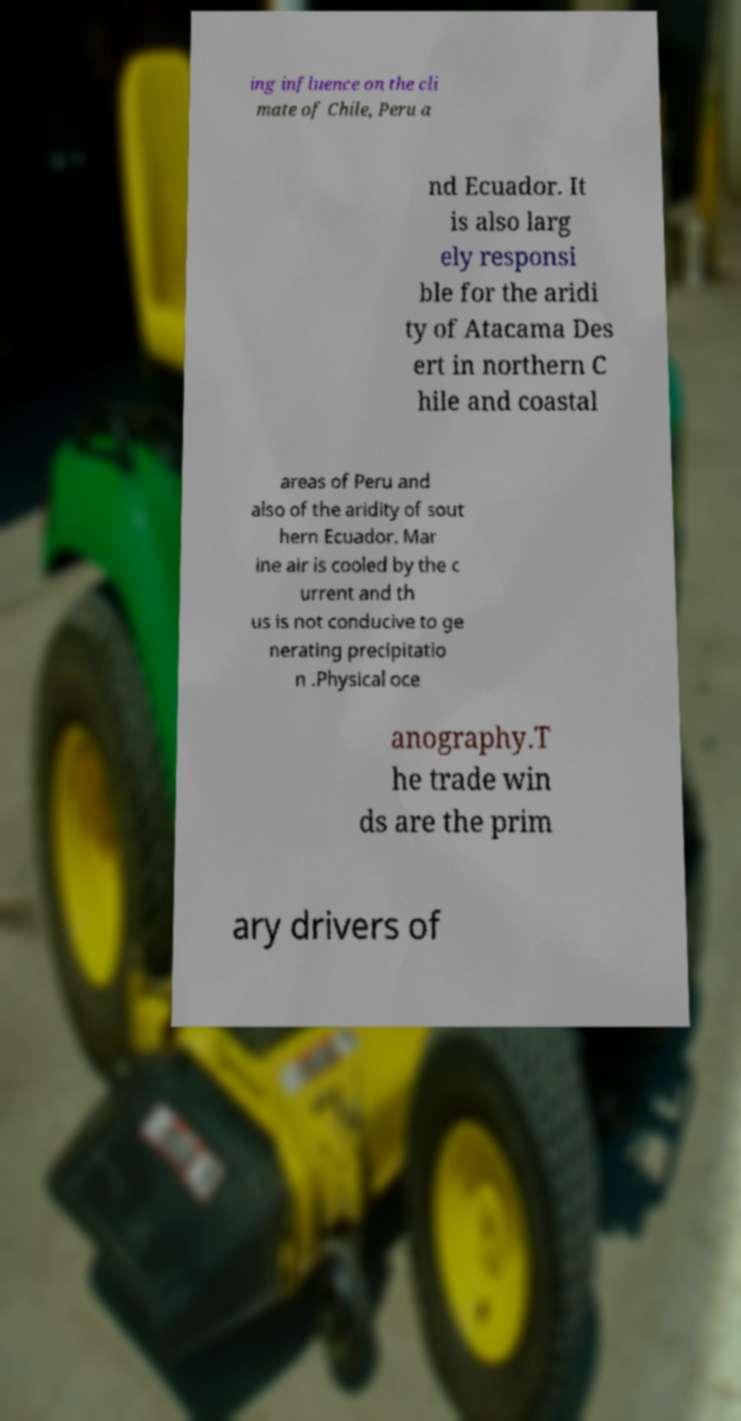For documentation purposes, I need the text within this image transcribed. Could you provide that? ing influence on the cli mate of Chile, Peru a nd Ecuador. It is also larg ely responsi ble for the aridi ty of Atacama Des ert in northern C hile and coastal areas of Peru and also of the aridity of sout hern Ecuador. Mar ine air is cooled by the c urrent and th us is not conducive to ge nerating precipitatio n .Physical oce anography.T he trade win ds are the prim ary drivers of 